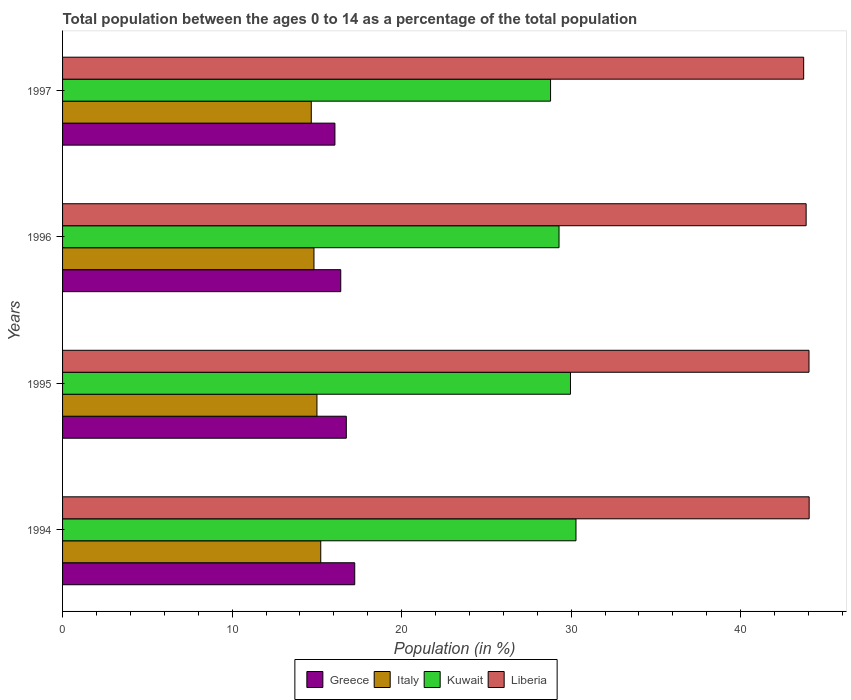What is the percentage of the population ages 0 to 14 in Italy in 1996?
Offer a very short reply. 14.83. Across all years, what is the maximum percentage of the population ages 0 to 14 in Kuwait?
Keep it short and to the point. 30.29. Across all years, what is the minimum percentage of the population ages 0 to 14 in Kuwait?
Make the answer very short. 28.79. What is the total percentage of the population ages 0 to 14 in Greece in the graph?
Make the answer very short. 66.45. What is the difference between the percentage of the population ages 0 to 14 in Greece in 1995 and that in 1997?
Offer a terse response. 0.67. What is the difference between the percentage of the population ages 0 to 14 in Liberia in 1994 and the percentage of the population ages 0 to 14 in Greece in 1997?
Your response must be concise. 27.97. What is the average percentage of the population ages 0 to 14 in Greece per year?
Provide a succinct answer. 16.61. In the year 1995, what is the difference between the percentage of the population ages 0 to 14 in Greece and percentage of the population ages 0 to 14 in Italy?
Offer a terse response. 1.73. In how many years, is the percentage of the population ages 0 to 14 in Kuwait greater than 42 ?
Give a very brief answer. 0. What is the ratio of the percentage of the population ages 0 to 14 in Italy in 1996 to that in 1997?
Offer a very short reply. 1.01. Is the difference between the percentage of the population ages 0 to 14 in Greece in 1994 and 1996 greater than the difference between the percentage of the population ages 0 to 14 in Italy in 1994 and 1996?
Your response must be concise. Yes. What is the difference between the highest and the second highest percentage of the population ages 0 to 14 in Italy?
Your answer should be very brief. 0.22. What is the difference between the highest and the lowest percentage of the population ages 0 to 14 in Italy?
Keep it short and to the point. 0.56. In how many years, is the percentage of the population ages 0 to 14 in Greece greater than the average percentage of the population ages 0 to 14 in Greece taken over all years?
Your response must be concise. 2. Is it the case that in every year, the sum of the percentage of the population ages 0 to 14 in Kuwait and percentage of the population ages 0 to 14 in Greece is greater than the sum of percentage of the population ages 0 to 14 in Italy and percentage of the population ages 0 to 14 in Liberia?
Your answer should be very brief. Yes. What does the 2nd bar from the top in 1994 represents?
Ensure brevity in your answer.  Kuwait. What does the 4th bar from the bottom in 1996 represents?
Provide a short and direct response. Liberia. Is it the case that in every year, the sum of the percentage of the population ages 0 to 14 in Kuwait and percentage of the population ages 0 to 14 in Greece is greater than the percentage of the population ages 0 to 14 in Liberia?
Keep it short and to the point. Yes. How many bars are there?
Ensure brevity in your answer.  16. Are all the bars in the graph horizontal?
Your answer should be compact. Yes. What is the difference between two consecutive major ticks on the X-axis?
Offer a very short reply. 10. Where does the legend appear in the graph?
Provide a succinct answer. Bottom center. How many legend labels are there?
Provide a short and direct response. 4. What is the title of the graph?
Your answer should be compact. Total population between the ages 0 to 14 as a percentage of the total population. Does "Sudan" appear as one of the legend labels in the graph?
Provide a short and direct response. No. What is the label or title of the Y-axis?
Make the answer very short. Years. What is the Population (in %) of Greece in 1994?
Provide a short and direct response. 17.23. What is the Population (in %) of Italy in 1994?
Give a very brief answer. 15.23. What is the Population (in %) of Kuwait in 1994?
Offer a very short reply. 30.29. What is the Population (in %) of Liberia in 1994?
Offer a terse response. 44.04. What is the Population (in %) of Greece in 1995?
Provide a short and direct response. 16.74. What is the Population (in %) of Italy in 1995?
Your answer should be compact. 15.01. What is the Population (in %) in Kuwait in 1995?
Your answer should be compact. 29.96. What is the Population (in %) in Liberia in 1995?
Offer a very short reply. 44.03. What is the Population (in %) of Greece in 1996?
Your answer should be very brief. 16.41. What is the Population (in %) of Italy in 1996?
Ensure brevity in your answer.  14.83. What is the Population (in %) of Kuwait in 1996?
Offer a very short reply. 29.29. What is the Population (in %) in Liberia in 1996?
Your answer should be very brief. 43.86. What is the Population (in %) in Greece in 1997?
Provide a succinct answer. 16.07. What is the Population (in %) in Italy in 1997?
Make the answer very short. 14.67. What is the Population (in %) in Kuwait in 1997?
Make the answer very short. 28.79. What is the Population (in %) of Liberia in 1997?
Offer a terse response. 43.72. Across all years, what is the maximum Population (in %) of Greece?
Offer a very short reply. 17.23. Across all years, what is the maximum Population (in %) in Italy?
Provide a short and direct response. 15.23. Across all years, what is the maximum Population (in %) in Kuwait?
Ensure brevity in your answer.  30.29. Across all years, what is the maximum Population (in %) in Liberia?
Your response must be concise. 44.04. Across all years, what is the minimum Population (in %) in Greece?
Ensure brevity in your answer.  16.07. Across all years, what is the minimum Population (in %) in Italy?
Your answer should be compact. 14.67. Across all years, what is the minimum Population (in %) of Kuwait?
Offer a terse response. 28.79. Across all years, what is the minimum Population (in %) of Liberia?
Offer a terse response. 43.72. What is the total Population (in %) in Greece in the graph?
Provide a short and direct response. 66.45. What is the total Population (in %) of Italy in the graph?
Provide a succinct answer. 59.74. What is the total Population (in %) in Kuwait in the graph?
Your answer should be very brief. 118.32. What is the total Population (in %) in Liberia in the graph?
Provide a short and direct response. 175.65. What is the difference between the Population (in %) in Greece in 1994 and that in 1995?
Give a very brief answer. 0.5. What is the difference between the Population (in %) in Italy in 1994 and that in 1995?
Your answer should be very brief. 0.22. What is the difference between the Population (in %) of Kuwait in 1994 and that in 1995?
Give a very brief answer. 0.32. What is the difference between the Population (in %) of Liberia in 1994 and that in 1995?
Offer a very short reply. 0.01. What is the difference between the Population (in %) of Greece in 1994 and that in 1996?
Make the answer very short. 0.82. What is the difference between the Population (in %) of Italy in 1994 and that in 1996?
Give a very brief answer. 0.4. What is the difference between the Population (in %) of Kuwait in 1994 and that in 1996?
Ensure brevity in your answer.  1. What is the difference between the Population (in %) in Liberia in 1994 and that in 1996?
Provide a short and direct response. 0.18. What is the difference between the Population (in %) of Greece in 1994 and that in 1997?
Your answer should be compact. 1.17. What is the difference between the Population (in %) of Italy in 1994 and that in 1997?
Provide a short and direct response. 0.56. What is the difference between the Population (in %) of Kuwait in 1994 and that in 1997?
Keep it short and to the point. 1.5. What is the difference between the Population (in %) of Liberia in 1994 and that in 1997?
Offer a terse response. 0.32. What is the difference between the Population (in %) in Greece in 1995 and that in 1996?
Ensure brevity in your answer.  0.33. What is the difference between the Population (in %) in Italy in 1995 and that in 1996?
Provide a succinct answer. 0.18. What is the difference between the Population (in %) of Kuwait in 1995 and that in 1996?
Your answer should be very brief. 0.68. What is the difference between the Population (in %) in Liberia in 1995 and that in 1996?
Your answer should be very brief. 0.17. What is the difference between the Population (in %) of Greece in 1995 and that in 1997?
Your response must be concise. 0.67. What is the difference between the Population (in %) in Italy in 1995 and that in 1997?
Make the answer very short. 0.33. What is the difference between the Population (in %) in Kuwait in 1995 and that in 1997?
Your response must be concise. 1.18. What is the difference between the Population (in %) in Liberia in 1995 and that in 1997?
Keep it short and to the point. 0.31. What is the difference between the Population (in %) of Greece in 1996 and that in 1997?
Offer a very short reply. 0.34. What is the difference between the Population (in %) in Italy in 1996 and that in 1997?
Your answer should be very brief. 0.16. What is the difference between the Population (in %) of Kuwait in 1996 and that in 1997?
Your answer should be very brief. 0.5. What is the difference between the Population (in %) in Liberia in 1996 and that in 1997?
Keep it short and to the point. 0.15. What is the difference between the Population (in %) of Greece in 1994 and the Population (in %) of Italy in 1995?
Your response must be concise. 2.23. What is the difference between the Population (in %) of Greece in 1994 and the Population (in %) of Kuwait in 1995?
Your response must be concise. -12.73. What is the difference between the Population (in %) in Greece in 1994 and the Population (in %) in Liberia in 1995?
Provide a short and direct response. -26.8. What is the difference between the Population (in %) of Italy in 1994 and the Population (in %) of Kuwait in 1995?
Provide a succinct answer. -14.73. What is the difference between the Population (in %) of Italy in 1994 and the Population (in %) of Liberia in 1995?
Your answer should be very brief. -28.8. What is the difference between the Population (in %) of Kuwait in 1994 and the Population (in %) of Liberia in 1995?
Your answer should be very brief. -13.75. What is the difference between the Population (in %) of Greece in 1994 and the Population (in %) of Italy in 1996?
Your answer should be compact. 2.4. What is the difference between the Population (in %) in Greece in 1994 and the Population (in %) in Kuwait in 1996?
Your answer should be compact. -12.05. What is the difference between the Population (in %) in Greece in 1994 and the Population (in %) in Liberia in 1996?
Ensure brevity in your answer.  -26.63. What is the difference between the Population (in %) in Italy in 1994 and the Population (in %) in Kuwait in 1996?
Offer a very short reply. -14.06. What is the difference between the Population (in %) of Italy in 1994 and the Population (in %) of Liberia in 1996?
Make the answer very short. -28.63. What is the difference between the Population (in %) of Kuwait in 1994 and the Population (in %) of Liberia in 1996?
Your answer should be compact. -13.58. What is the difference between the Population (in %) in Greece in 1994 and the Population (in %) in Italy in 1997?
Your answer should be very brief. 2.56. What is the difference between the Population (in %) in Greece in 1994 and the Population (in %) in Kuwait in 1997?
Your response must be concise. -11.55. What is the difference between the Population (in %) of Greece in 1994 and the Population (in %) of Liberia in 1997?
Offer a very short reply. -26.48. What is the difference between the Population (in %) in Italy in 1994 and the Population (in %) in Kuwait in 1997?
Keep it short and to the point. -13.56. What is the difference between the Population (in %) of Italy in 1994 and the Population (in %) of Liberia in 1997?
Make the answer very short. -28.49. What is the difference between the Population (in %) of Kuwait in 1994 and the Population (in %) of Liberia in 1997?
Provide a succinct answer. -13.43. What is the difference between the Population (in %) in Greece in 1995 and the Population (in %) in Italy in 1996?
Keep it short and to the point. 1.91. What is the difference between the Population (in %) in Greece in 1995 and the Population (in %) in Kuwait in 1996?
Ensure brevity in your answer.  -12.55. What is the difference between the Population (in %) of Greece in 1995 and the Population (in %) of Liberia in 1996?
Make the answer very short. -27.12. What is the difference between the Population (in %) of Italy in 1995 and the Population (in %) of Kuwait in 1996?
Your answer should be compact. -14.28. What is the difference between the Population (in %) in Italy in 1995 and the Population (in %) in Liberia in 1996?
Provide a succinct answer. -28.86. What is the difference between the Population (in %) of Kuwait in 1995 and the Population (in %) of Liberia in 1996?
Ensure brevity in your answer.  -13.9. What is the difference between the Population (in %) in Greece in 1995 and the Population (in %) in Italy in 1997?
Ensure brevity in your answer.  2.07. What is the difference between the Population (in %) of Greece in 1995 and the Population (in %) of Kuwait in 1997?
Ensure brevity in your answer.  -12.05. What is the difference between the Population (in %) of Greece in 1995 and the Population (in %) of Liberia in 1997?
Provide a short and direct response. -26.98. What is the difference between the Population (in %) in Italy in 1995 and the Population (in %) in Kuwait in 1997?
Give a very brief answer. -13.78. What is the difference between the Population (in %) of Italy in 1995 and the Population (in %) of Liberia in 1997?
Offer a terse response. -28.71. What is the difference between the Population (in %) in Kuwait in 1995 and the Population (in %) in Liberia in 1997?
Your answer should be very brief. -13.76. What is the difference between the Population (in %) in Greece in 1996 and the Population (in %) in Italy in 1997?
Make the answer very short. 1.74. What is the difference between the Population (in %) of Greece in 1996 and the Population (in %) of Kuwait in 1997?
Your answer should be compact. -12.38. What is the difference between the Population (in %) in Greece in 1996 and the Population (in %) in Liberia in 1997?
Provide a succinct answer. -27.31. What is the difference between the Population (in %) in Italy in 1996 and the Population (in %) in Kuwait in 1997?
Offer a terse response. -13.96. What is the difference between the Population (in %) in Italy in 1996 and the Population (in %) in Liberia in 1997?
Make the answer very short. -28.89. What is the difference between the Population (in %) in Kuwait in 1996 and the Population (in %) in Liberia in 1997?
Provide a short and direct response. -14.43. What is the average Population (in %) of Greece per year?
Keep it short and to the point. 16.61. What is the average Population (in %) of Italy per year?
Make the answer very short. 14.93. What is the average Population (in %) of Kuwait per year?
Offer a terse response. 29.58. What is the average Population (in %) in Liberia per year?
Ensure brevity in your answer.  43.91. In the year 1994, what is the difference between the Population (in %) of Greece and Population (in %) of Italy?
Offer a very short reply. 2. In the year 1994, what is the difference between the Population (in %) of Greece and Population (in %) of Kuwait?
Provide a short and direct response. -13.05. In the year 1994, what is the difference between the Population (in %) of Greece and Population (in %) of Liberia?
Offer a very short reply. -26.81. In the year 1994, what is the difference between the Population (in %) in Italy and Population (in %) in Kuwait?
Provide a short and direct response. -15.06. In the year 1994, what is the difference between the Population (in %) of Italy and Population (in %) of Liberia?
Give a very brief answer. -28.81. In the year 1994, what is the difference between the Population (in %) of Kuwait and Population (in %) of Liberia?
Your answer should be compact. -13.76. In the year 1995, what is the difference between the Population (in %) of Greece and Population (in %) of Italy?
Provide a short and direct response. 1.73. In the year 1995, what is the difference between the Population (in %) of Greece and Population (in %) of Kuwait?
Keep it short and to the point. -13.22. In the year 1995, what is the difference between the Population (in %) of Greece and Population (in %) of Liberia?
Provide a short and direct response. -27.29. In the year 1995, what is the difference between the Population (in %) of Italy and Population (in %) of Kuwait?
Your answer should be very brief. -14.96. In the year 1995, what is the difference between the Population (in %) of Italy and Population (in %) of Liberia?
Make the answer very short. -29.03. In the year 1995, what is the difference between the Population (in %) of Kuwait and Population (in %) of Liberia?
Keep it short and to the point. -14.07. In the year 1996, what is the difference between the Population (in %) of Greece and Population (in %) of Italy?
Offer a very short reply. 1.58. In the year 1996, what is the difference between the Population (in %) in Greece and Population (in %) in Kuwait?
Keep it short and to the point. -12.88. In the year 1996, what is the difference between the Population (in %) of Greece and Population (in %) of Liberia?
Offer a very short reply. -27.45. In the year 1996, what is the difference between the Population (in %) of Italy and Population (in %) of Kuwait?
Offer a terse response. -14.46. In the year 1996, what is the difference between the Population (in %) of Italy and Population (in %) of Liberia?
Provide a short and direct response. -29.03. In the year 1996, what is the difference between the Population (in %) of Kuwait and Population (in %) of Liberia?
Provide a succinct answer. -14.58. In the year 1997, what is the difference between the Population (in %) in Greece and Population (in %) in Italy?
Make the answer very short. 1.39. In the year 1997, what is the difference between the Population (in %) in Greece and Population (in %) in Kuwait?
Your answer should be compact. -12.72. In the year 1997, what is the difference between the Population (in %) in Greece and Population (in %) in Liberia?
Your answer should be very brief. -27.65. In the year 1997, what is the difference between the Population (in %) in Italy and Population (in %) in Kuwait?
Provide a short and direct response. -14.11. In the year 1997, what is the difference between the Population (in %) of Italy and Population (in %) of Liberia?
Your answer should be compact. -29.05. In the year 1997, what is the difference between the Population (in %) in Kuwait and Population (in %) in Liberia?
Make the answer very short. -14.93. What is the ratio of the Population (in %) in Greece in 1994 to that in 1995?
Make the answer very short. 1.03. What is the ratio of the Population (in %) of Italy in 1994 to that in 1995?
Provide a succinct answer. 1.01. What is the ratio of the Population (in %) of Kuwait in 1994 to that in 1995?
Your response must be concise. 1.01. What is the ratio of the Population (in %) in Liberia in 1994 to that in 1995?
Ensure brevity in your answer.  1. What is the ratio of the Population (in %) in Greece in 1994 to that in 1996?
Ensure brevity in your answer.  1.05. What is the ratio of the Population (in %) of Italy in 1994 to that in 1996?
Your answer should be very brief. 1.03. What is the ratio of the Population (in %) in Kuwait in 1994 to that in 1996?
Keep it short and to the point. 1.03. What is the ratio of the Population (in %) in Greece in 1994 to that in 1997?
Offer a very short reply. 1.07. What is the ratio of the Population (in %) in Italy in 1994 to that in 1997?
Give a very brief answer. 1.04. What is the ratio of the Population (in %) in Kuwait in 1994 to that in 1997?
Ensure brevity in your answer.  1.05. What is the ratio of the Population (in %) of Liberia in 1994 to that in 1997?
Provide a short and direct response. 1.01. What is the ratio of the Population (in %) of Italy in 1995 to that in 1996?
Give a very brief answer. 1.01. What is the ratio of the Population (in %) of Kuwait in 1995 to that in 1996?
Ensure brevity in your answer.  1.02. What is the ratio of the Population (in %) in Liberia in 1995 to that in 1996?
Your answer should be very brief. 1. What is the ratio of the Population (in %) in Greece in 1995 to that in 1997?
Ensure brevity in your answer.  1.04. What is the ratio of the Population (in %) in Italy in 1995 to that in 1997?
Offer a terse response. 1.02. What is the ratio of the Population (in %) in Kuwait in 1995 to that in 1997?
Provide a short and direct response. 1.04. What is the ratio of the Population (in %) in Liberia in 1995 to that in 1997?
Offer a terse response. 1.01. What is the ratio of the Population (in %) of Greece in 1996 to that in 1997?
Your answer should be compact. 1.02. What is the ratio of the Population (in %) in Italy in 1996 to that in 1997?
Make the answer very short. 1.01. What is the ratio of the Population (in %) of Kuwait in 1996 to that in 1997?
Keep it short and to the point. 1.02. What is the difference between the highest and the second highest Population (in %) of Greece?
Your answer should be compact. 0.5. What is the difference between the highest and the second highest Population (in %) of Italy?
Your answer should be compact. 0.22. What is the difference between the highest and the second highest Population (in %) in Kuwait?
Your answer should be very brief. 0.32. What is the difference between the highest and the second highest Population (in %) in Liberia?
Provide a succinct answer. 0.01. What is the difference between the highest and the lowest Population (in %) of Greece?
Your answer should be very brief. 1.17. What is the difference between the highest and the lowest Population (in %) in Italy?
Your response must be concise. 0.56. What is the difference between the highest and the lowest Population (in %) of Kuwait?
Your response must be concise. 1.5. What is the difference between the highest and the lowest Population (in %) of Liberia?
Your answer should be very brief. 0.32. 